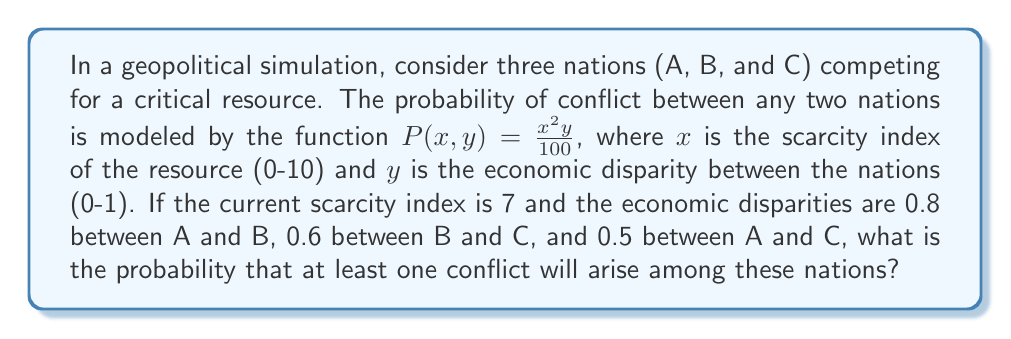Teach me how to tackle this problem. Let's approach this step-by-step:

1) First, we need to calculate the probability of conflict for each pair of nations:

   For A and B: $P(7,0.8) = \frac{7^2 \cdot 0.8}{100} = \frac{39.2}{100} = 0.392$
   For B and C: $P(7,0.6) = \frac{7^2 \cdot 0.6}{100} = \frac{29.4}{100} = 0.294$
   For A and C: $P(7,0.5) = \frac{7^2 \cdot 0.5}{100} = \frac{24.5}{100} = 0.245$

2) Now, we need to find the probability that at least one conflict will arise. This is equivalent to 1 minus the probability that no conflicts arise.

3) The probability of no conflict between A and B is (1 - 0.392) = 0.608
   The probability of no conflict between B and C is (1 - 0.294) = 0.706
   The probability of no conflict between A and C is (1 - 0.245) = 0.755

4) For no conflicts to occur at all, all three of these independent events must occur simultaneously. So we multiply these probabilities:

   $P(\text{no conflicts}) = 0.608 \cdot 0.706 \cdot 0.755 = 0.3234$

5) Therefore, the probability of at least one conflict is:

   $P(\text{at least one conflict}) = 1 - P(\text{no conflicts}) = 1 - 0.3234 = 0.6766$
Answer: 0.6766 